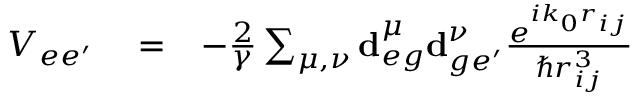Convert formula to latex. <formula><loc_0><loc_0><loc_500><loc_500>\begin{array} { r l r } { V _ { e e ^ { \prime } } } & = } & { - \frac { 2 } { \gamma } \sum _ { \mu , \nu } d _ { e g } ^ { \mu } d _ { g e ^ { \prime } } ^ { \nu } \frac { e ^ { i k _ { 0 } r _ { i j } } } { \hbar { r } _ { i j } ^ { 3 } } } \end{array}</formula> 